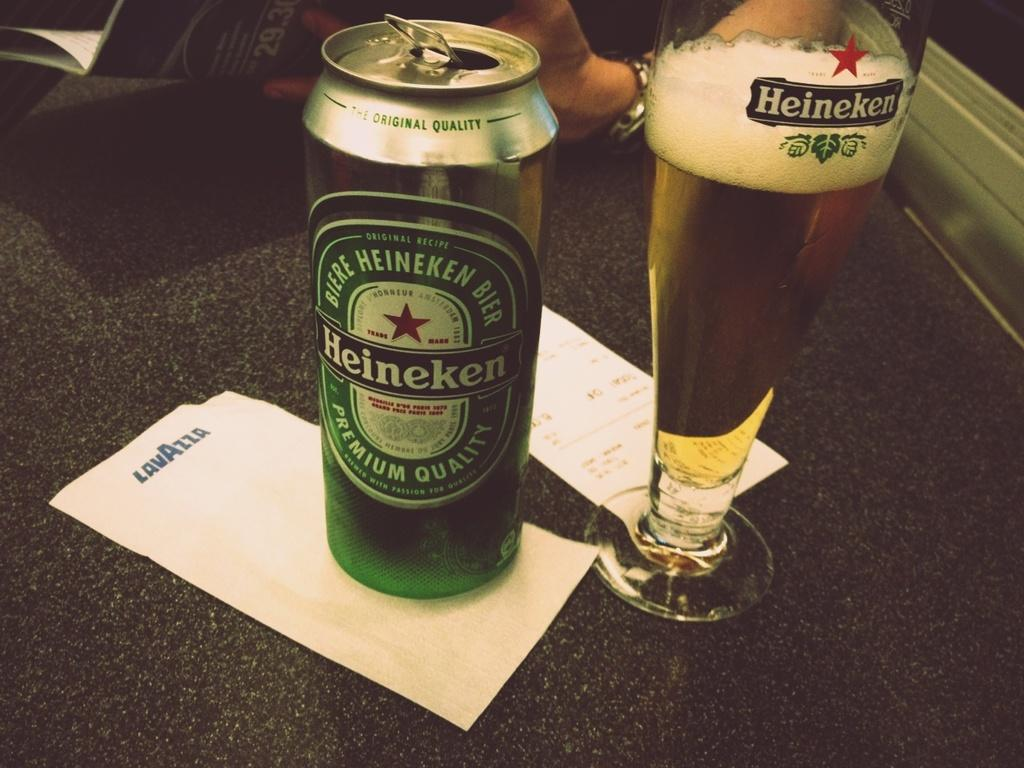<image>
Describe the image concisely. A can of Heineken beer has been poured into a glass on a table. 